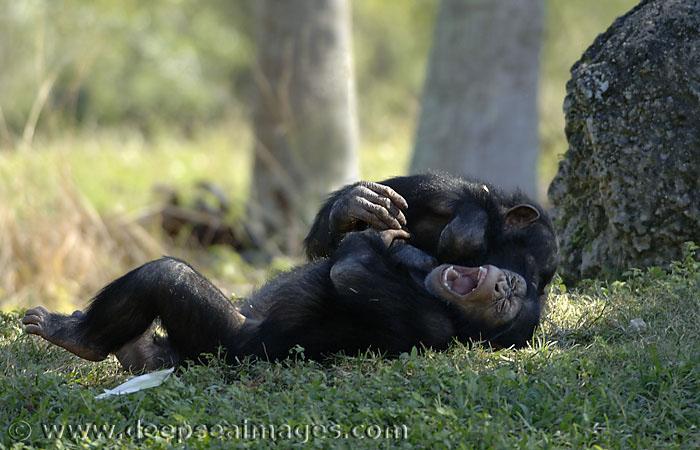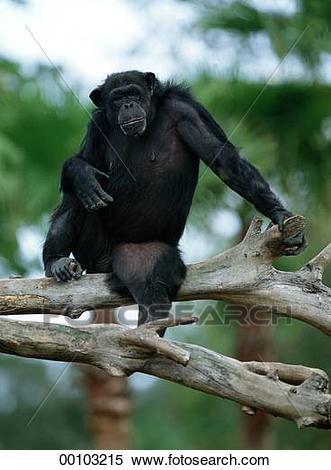The first image is the image on the left, the second image is the image on the right. Examine the images to the left and right. Is the description "An image shows one non-sleeping chimp, which is perched on a wooden object." accurate? Answer yes or no. Yes. 